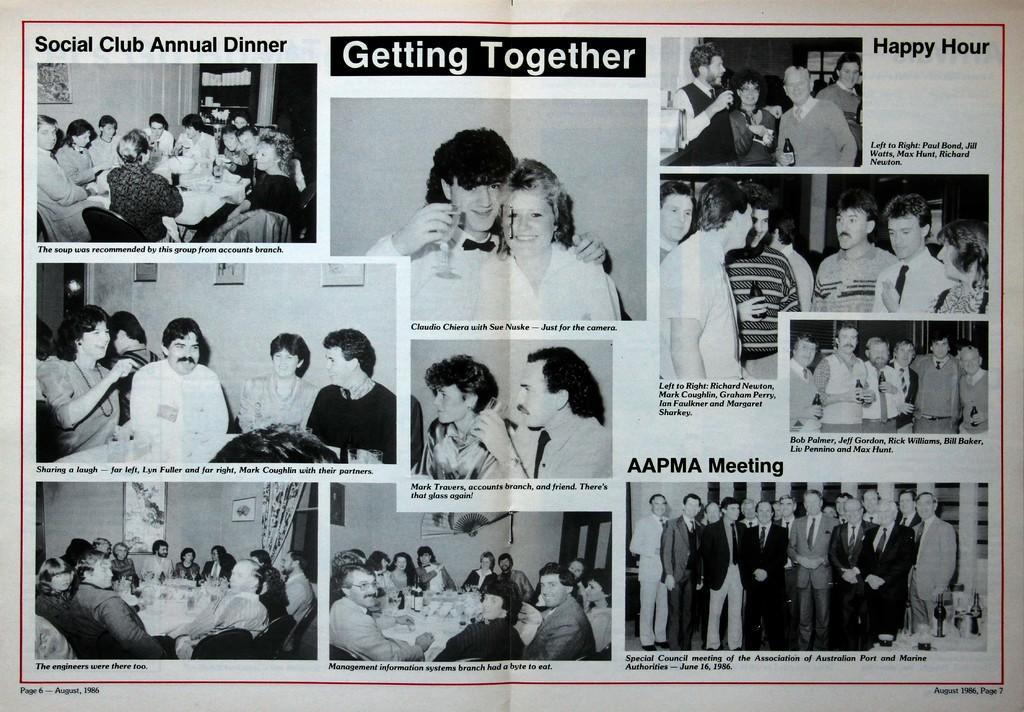In one or two sentences, can you explain what this image depicts? In the image we can see a paper, on the paper few people are standing and sitting and holding glasses. 